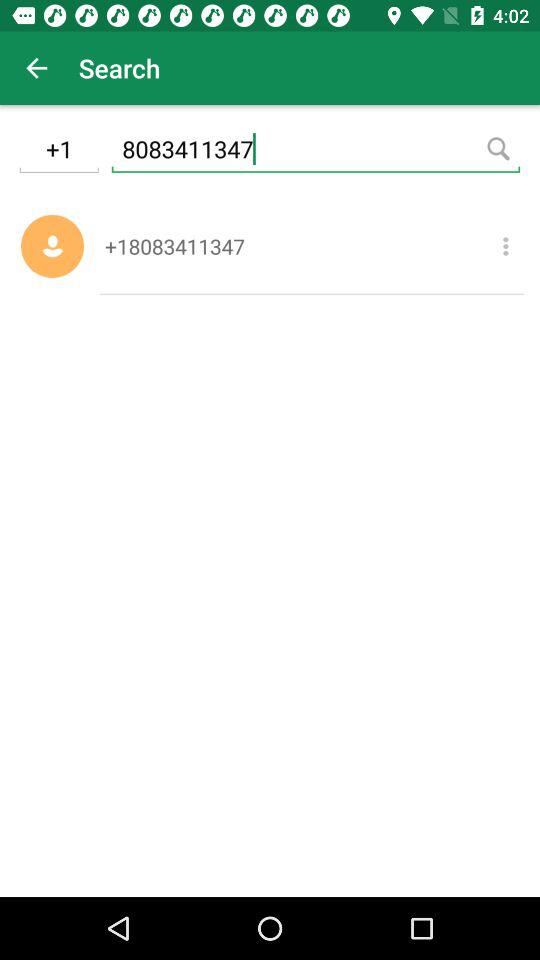What is the contact number? The contact number is +18083411347. 